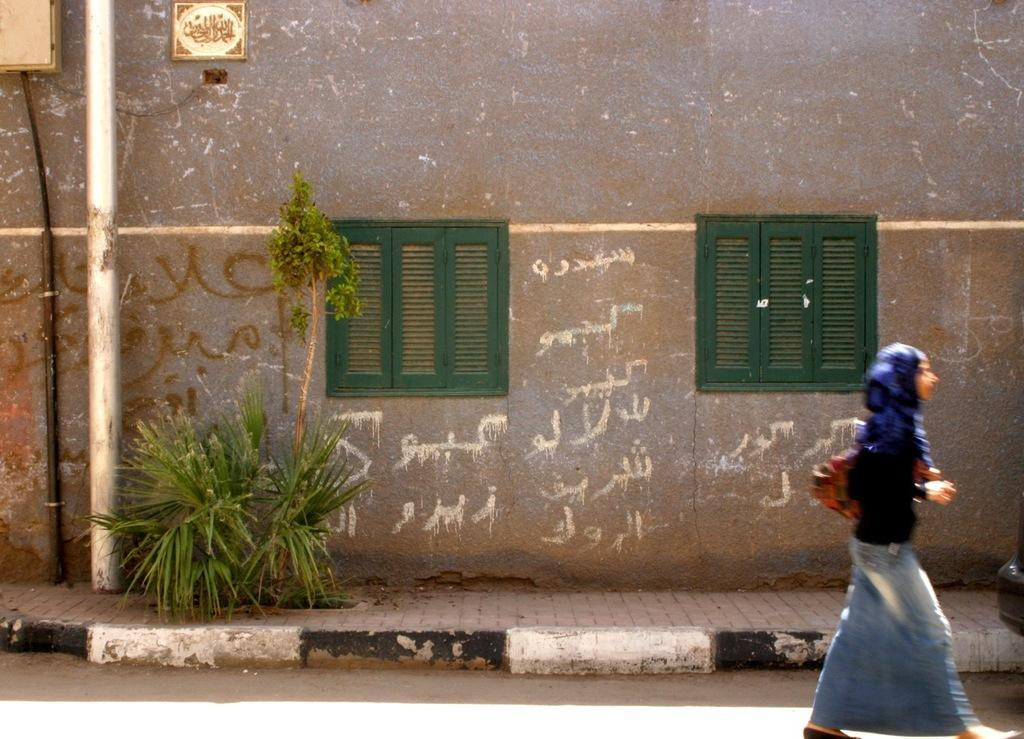What is the main subject of the image? There is a woman in the image. What is the woman carrying? The woman is carrying a bag. What is the woman doing in the image? The woman is walking on the road. What can be seen in the background of the image? There is a pole, plants, and a wall with windows and boards in the background of the image. What type of apparatus is the woman using to measure her interest in the flower? There is no apparatus or flower present in the image; it only features a woman walking on the road with a bag and a background with a pole, plants, and a wall with windows and boards. 